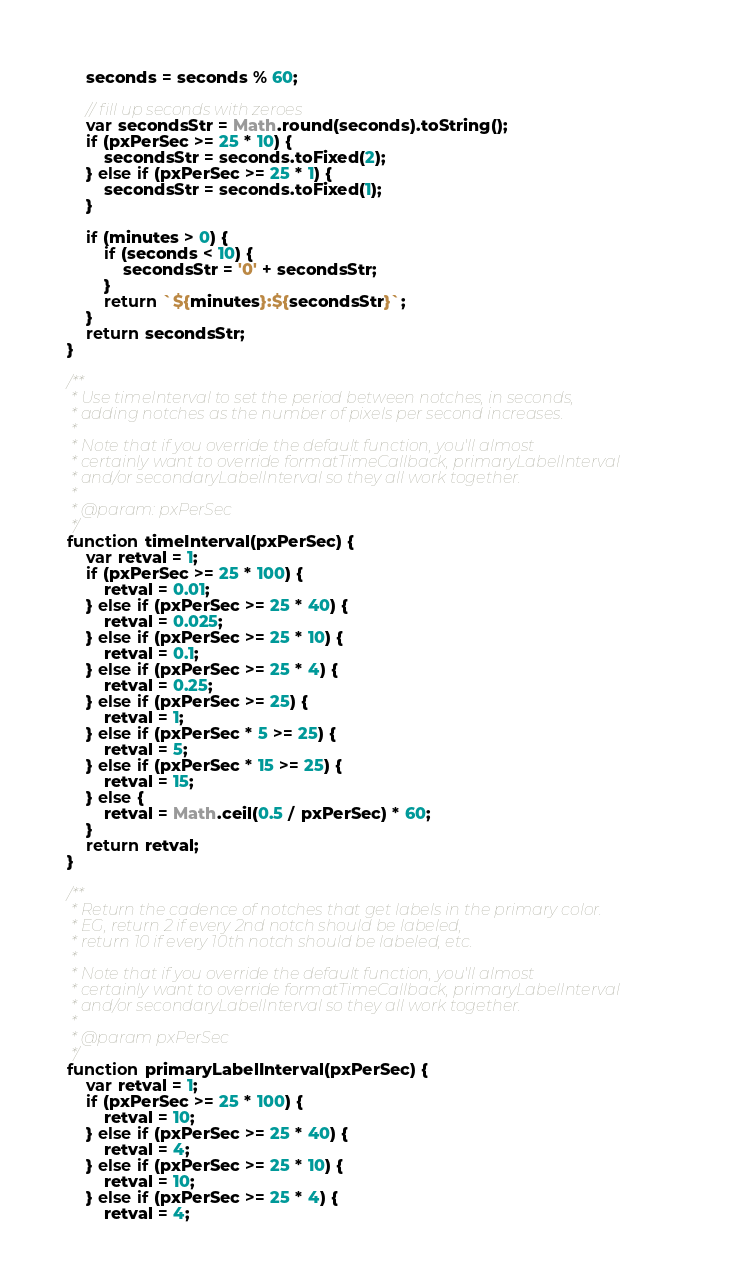Convert code to text. <code><loc_0><loc_0><loc_500><loc_500><_JavaScript_>    seconds = seconds % 60;

    // fill up seconds with zeroes
    var secondsStr = Math.round(seconds).toString();
    if (pxPerSec >= 25 * 10) {
        secondsStr = seconds.toFixed(2);
    } else if (pxPerSec >= 25 * 1) {
        secondsStr = seconds.toFixed(1);
    }

    if (minutes > 0) {
        if (seconds < 10) {
            secondsStr = '0' + secondsStr;
        }
        return `${minutes}:${secondsStr}`;
    }
    return secondsStr;
}

/**
 * Use timeInterval to set the period between notches, in seconds,
 * adding notches as the number of pixels per second increases.
 *
 * Note that if you override the default function, you'll almost
 * certainly want to override formatTimeCallback, primaryLabelInterval
 * and/or secondaryLabelInterval so they all work together.
 *
 * @param: pxPerSec
 */
function timeInterval(pxPerSec) {
    var retval = 1;
    if (pxPerSec >= 25 * 100) {
        retval = 0.01;
    } else if (pxPerSec >= 25 * 40) {
        retval = 0.025;
    } else if (pxPerSec >= 25 * 10) {
        retval = 0.1;
    } else if (pxPerSec >= 25 * 4) {
        retval = 0.25;
    } else if (pxPerSec >= 25) {
        retval = 1;
    } else if (pxPerSec * 5 >= 25) {
        retval = 5;
    } else if (pxPerSec * 15 >= 25) {
        retval = 15;
    } else {
        retval = Math.ceil(0.5 / pxPerSec) * 60;
    }
    return retval;
}

/**
 * Return the cadence of notches that get labels in the primary color.
 * EG, return 2 if every 2nd notch should be labeled,
 * return 10 if every 10th notch should be labeled, etc.
 *
 * Note that if you override the default function, you'll almost
 * certainly want to override formatTimeCallback, primaryLabelInterval
 * and/or secondaryLabelInterval so they all work together.
 *
 * @param pxPerSec
 */
function primaryLabelInterval(pxPerSec) {
    var retval = 1;
    if (pxPerSec >= 25 * 100) {
        retval = 10;
    } else if (pxPerSec >= 25 * 40) {
        retval = 4;
    } else if (pxPerSec >= 25 * 10) {
        retval = 10;
    } else if (pxPerSec >= 25 * 4) {
        retval = 4;</code> 